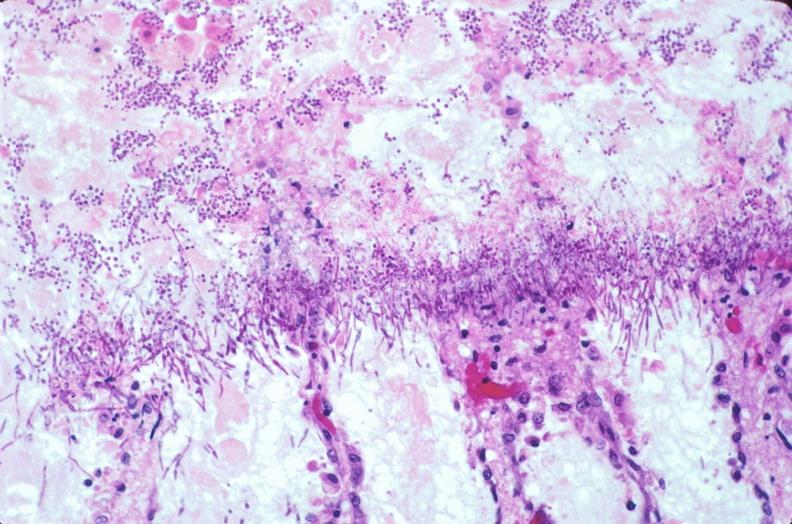s malignant lymphoma present?
Answer the question using a single word or phrase. No 